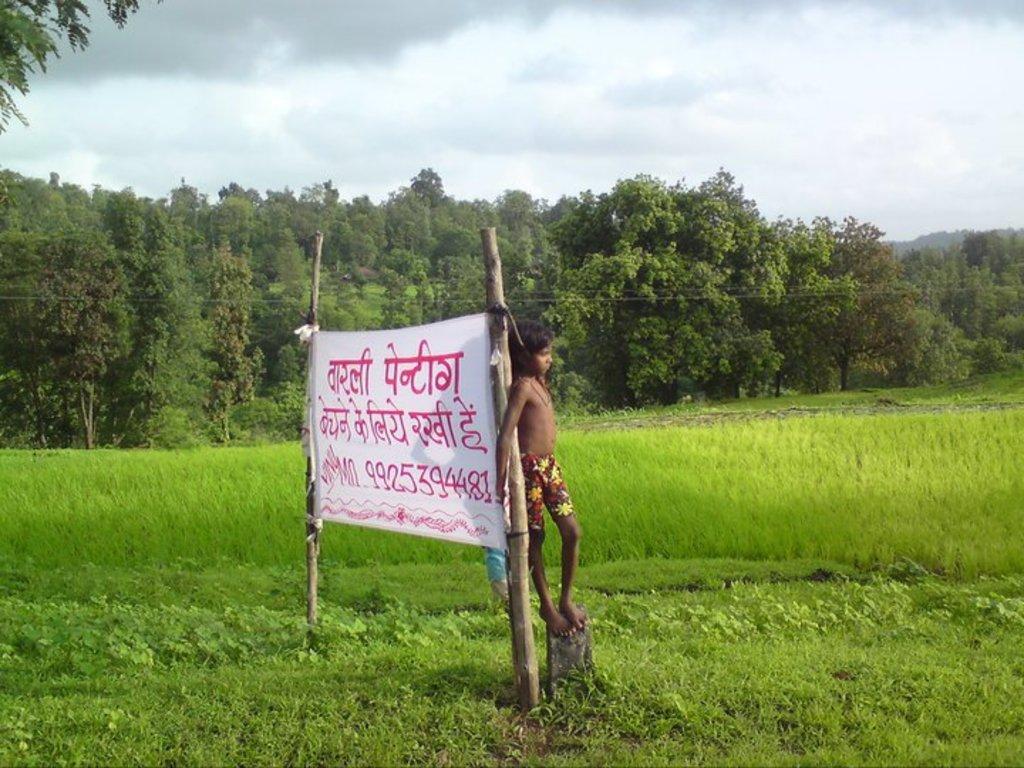Can you describe this image briefly? In this image there is a kid standing on the rock is leaning on to a wooden pole with banner to it, behind the kid there is crop and trees, at the top of the image there are clouds in the sky. 